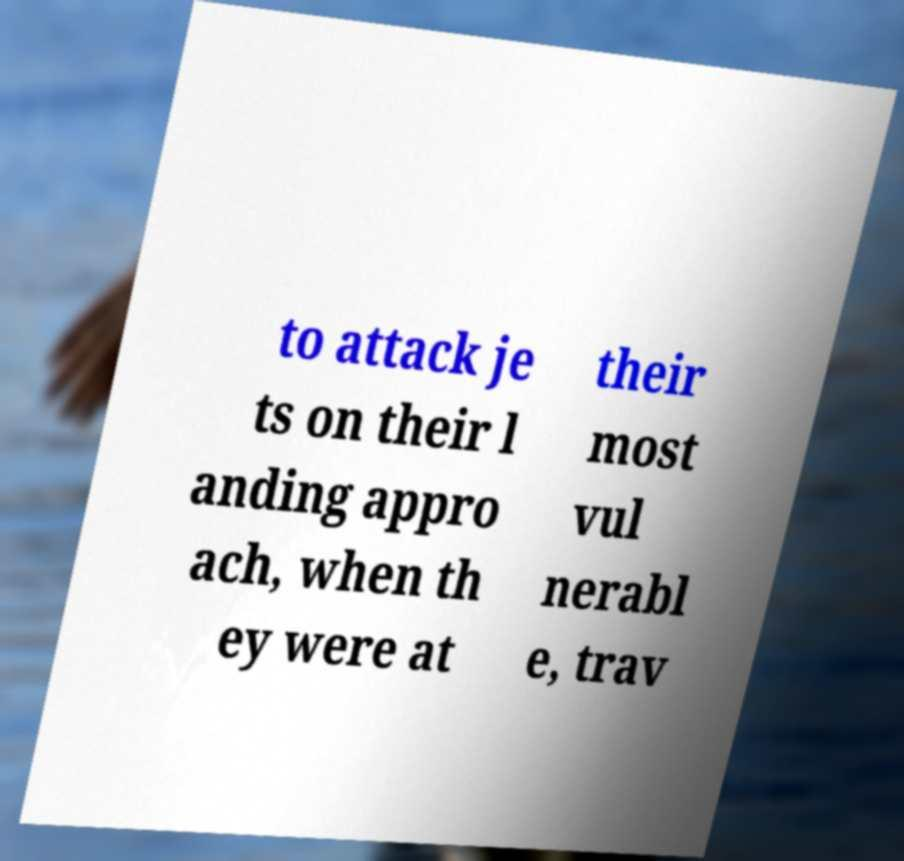Please read and relay the text visible in this image. What does it say? to attack je ts on their l anding appro ach, when th ey were at their most vul nerabl e, trav 